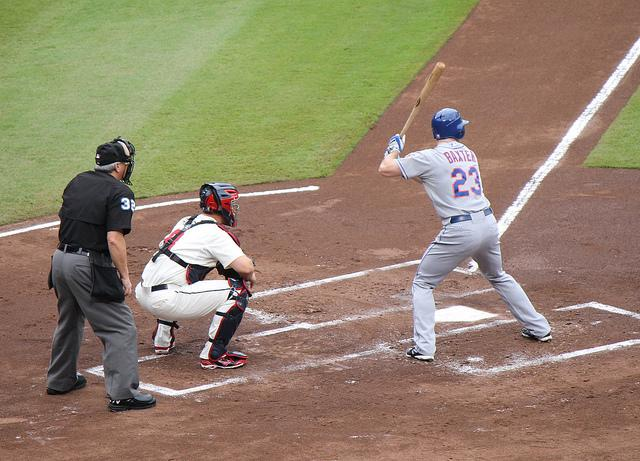Who is the away team? mets 